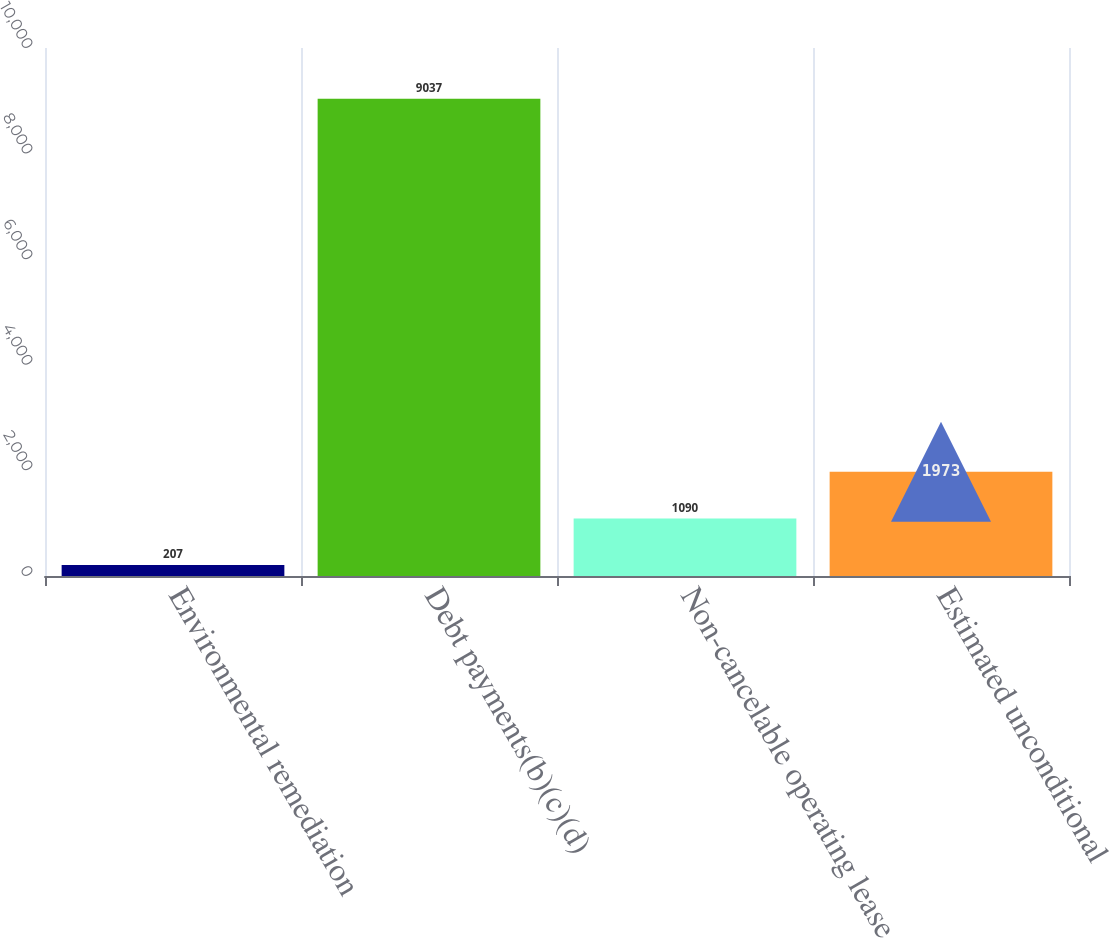Convert chart to OTSL. <chart><loc_0><loc_0><loc_500><loc_500><bar_chart><fcel>Environmental remediation<fcel>Debt payments(b)(c)(d)<fcel>Non-cancelable operating lease<fcel>Estimated unconditional<nl><fcel>207<fcel>9037<fcel>1090<fcel>1973<nl></chart> 